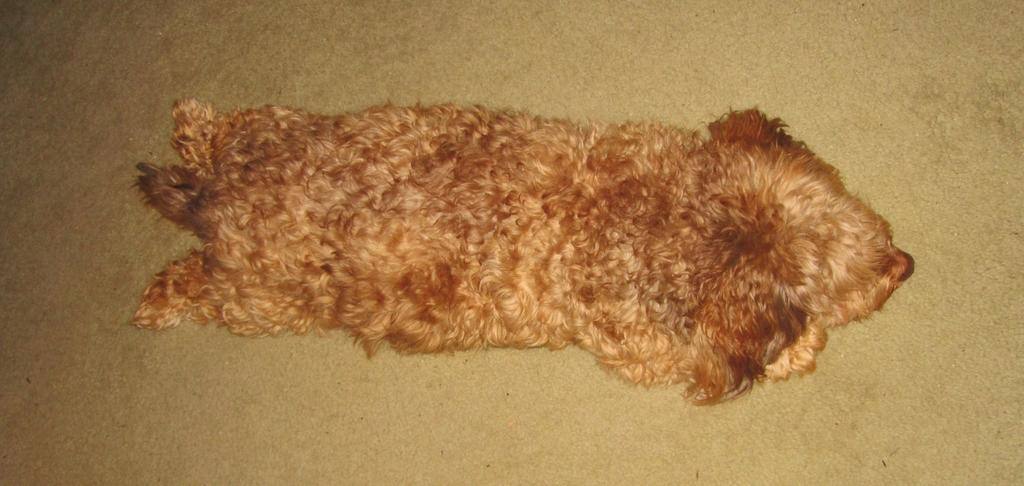What type of animal is in the image? There is a dog in the image. What color is the dog? The dog is brown in color. What surface is visible in the image? There is a floor visible in the image. What type of stone is the dog holding in the image? There is no stone present in the image; the dog is not holding anything. 